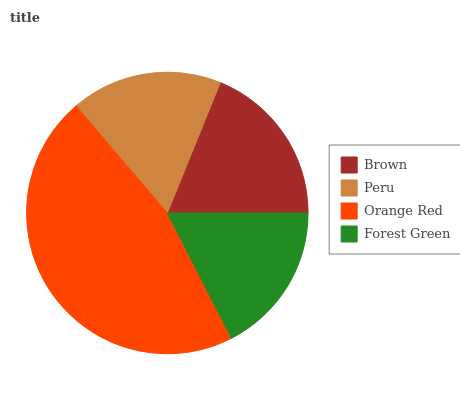Is Peru the minimum?
Answer yes or no. Yes. Is Orange Red the maximum?
Answer yes or no. Yes. Is Orange Red the minimum?
Answer yes or no. No. Is Peru the maximum?
Answer yes or no. No. Is Orange Red greater than Peru?
Answer yes or no. Yes. Is Peru less than Orange Red?
Answer yes or no. Yes. Is Peru greater than Orange Red?
Answer yes or no. No. Is Orange Red less than Peru?
Answer yes or no. No. Is Brown the high median?
Answer yes or no. Yes. Is Forest Green the low median?
Answer yes or no. Yes. Is Orange Red the high median?
Answer yes or no. No. Is Orange Red the low median?
Answer yes or no. No. 